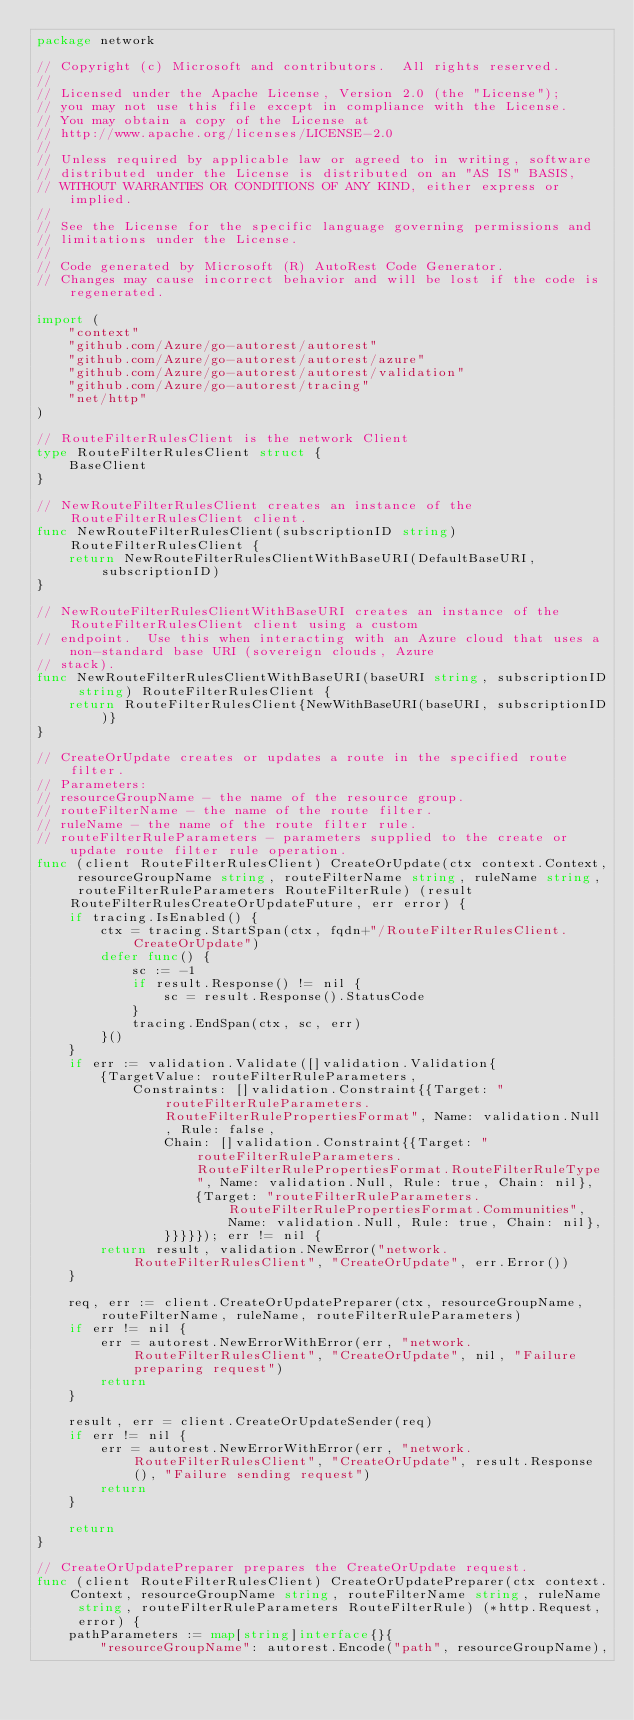Convert code to text. <code><loc_0><loc_0><loc_500><loc_500><_Go_>package network

// Copyright (c) Microsoft and contributors.  All rights reserved.
//
// Licensed under the Apache License, Version 2.0 (the "License");
// you may not use this file except in compliance with the License.
// You may obtain a copy of the License at
// http://www.apache.org/licenses/LICENSE-2.0
//
// Unless required by applicable law or agreed to in writing, software
// distributed under the License is distributed on an "AS IS" BASIS,
// WITHOUT WARRANTIES OR CONDITIONS OF ANY KIND, either express or implied.
//
// See the License for the specific language governing permissions and
// limitations under the License.
//
// Code generated by Microsoft (R) AutoRest Code Generator.
// Changes may cause incorrect behavior and will be lost if the code is regenerated.

import (
	"context"
	"github.com/Azure/go-autorest/autorest"
	"github.com/Azure/go-autorest/autorest/azure"
	"github.com/Azure/go-autorest/autorest/validation"
	"github.com/Azure/go-autorest/tracing"
	"net/http"
)

// RouteFilterRulesClient is the network Client
type RouteFilterRulesClient struct {
	BaseClient
}

// NewRouteFilterRulesClient creates an instance of the RouteFilterRulesClient client.
func NewRouteFilterRulesClient(subscriptionID string) RouteFilterRulesClient {
	return NewRouteFilterRulesClientWithBaseURI(DefaultBaseURI, subscriptionID)
}

// NewRouteFilterRulesClientWithBaseURI creates an instance of the RouteFilterRulesClient client using a custom
// endpoint.  Use this when interacting with an Azure cloud that uses a non-standard base URI (sovereign clouds, Azure
// stack).
func NewRouteFilterRulesClientWithBaseURI(baseURI string, subscriptionID string) RouteFilterRulesClient {
	return RouteFilterRulesClient{NewWithBaseURI(baseURI, subscriptionID)}
}

// CreateOrUpdate creates or updates a route in the specified route filter.
// Parameters:
// resourceGroupName - the name of the resource group.
// routeFilterName - the name of the route filter.
// ruleName - the name of the route filter rule.
// routeFilterRuleParameters - parameters supplied to the create or update route filter rule operation.
func (client RouteFilterRulesClient) CreateOrUpdate(ctx context.Context, resourceGroupName string, routeFilterName string, ruleName string, routeFilterRuleParameters RouteFilterRule) (result RouteFilterRulesCreateOrUpdateFuture, err error) {
	if tracing.IsEnabled() {
		ctx = tracing.StartSpan(ctx, fqdn+"/RouteFilterRulesClient.CreateOrUpdate")
		defer func() {
			sc := -1
			if result.Response() != nil {
				sc = result.Response().StatusCode
			}
			tracing.EndSpan(ctx, sc, err)
		}()
	}
	if err := validation.Validate([]validation.Validation{
		{TargetValue: routeFilterRuleParameters,
			Constraints: []validation.Constraint{{Target: "routeFilterRuleParameters.RouteFilterRulePropertiesFormat", Name: validation.Null, Rule: false,
				Chain: []validation.Constraint{{Target: "routeFilterRuleParameters.RouteFilterRulePropertiesFormat.RouteFilterRuleType", Name: validation.Null, Rule: true, Chain: nil},
					{Target: "routeFilterRuleParameters.RouteFilterRulePropertiesFormat.Communities", Name: validation.Null, Rule: true, Chain: nil},
				}}}}}); err != nil {
		return result, validation.NewError("network.RouteFilterRulesClient", "CreateOrUpdate", err.Error())
	}

	req, err := client.CreateOrUpdatePreparer(ctx, resourceGroupName, routeFilterName, ruleName, routeFilterRuleParameters)
	if err != nil {
		err = autorest.NewErrorWithError(err, "network.RouteFilterRulesClient", "CreateOrUpdate", nil, "Failure preparing request")
		return
	}

	result, err = client.CreateOrUpdateSender(req)
	if err != nil {
		err = autorest.NewErrorWithError(err, "network.RouteFilterRulesClient", "CreateOrUpdate", result.Response(), "Failure sending request")
		return
	}

	return
}

// CreateOrUpdatePreparer prepares the CreateOrUpdate request.
func (client RouteFilterRulesClient) CreateOrUpdatePreparer(ctx context.Context, resourceGroupName string, routeFilterName string, ruleName string, routeFilterRuleParameters RouteFilterRule) (*http.Request, error) {
	pathParameters := map[string]interface{}{
		"resourceGroupName": autorest.Encode("path", resourceGroupName),</code> 